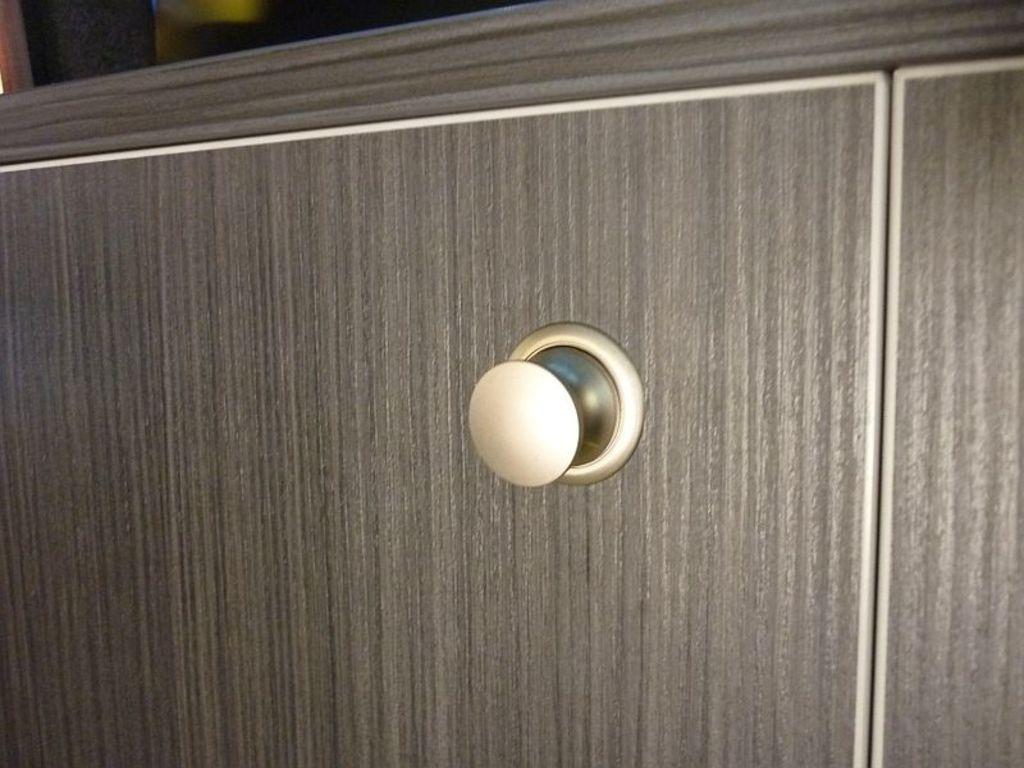Describe this image in one or two sentences. In this image I can see the cupboard which is in cream and grey color. And there is a blurred background. 